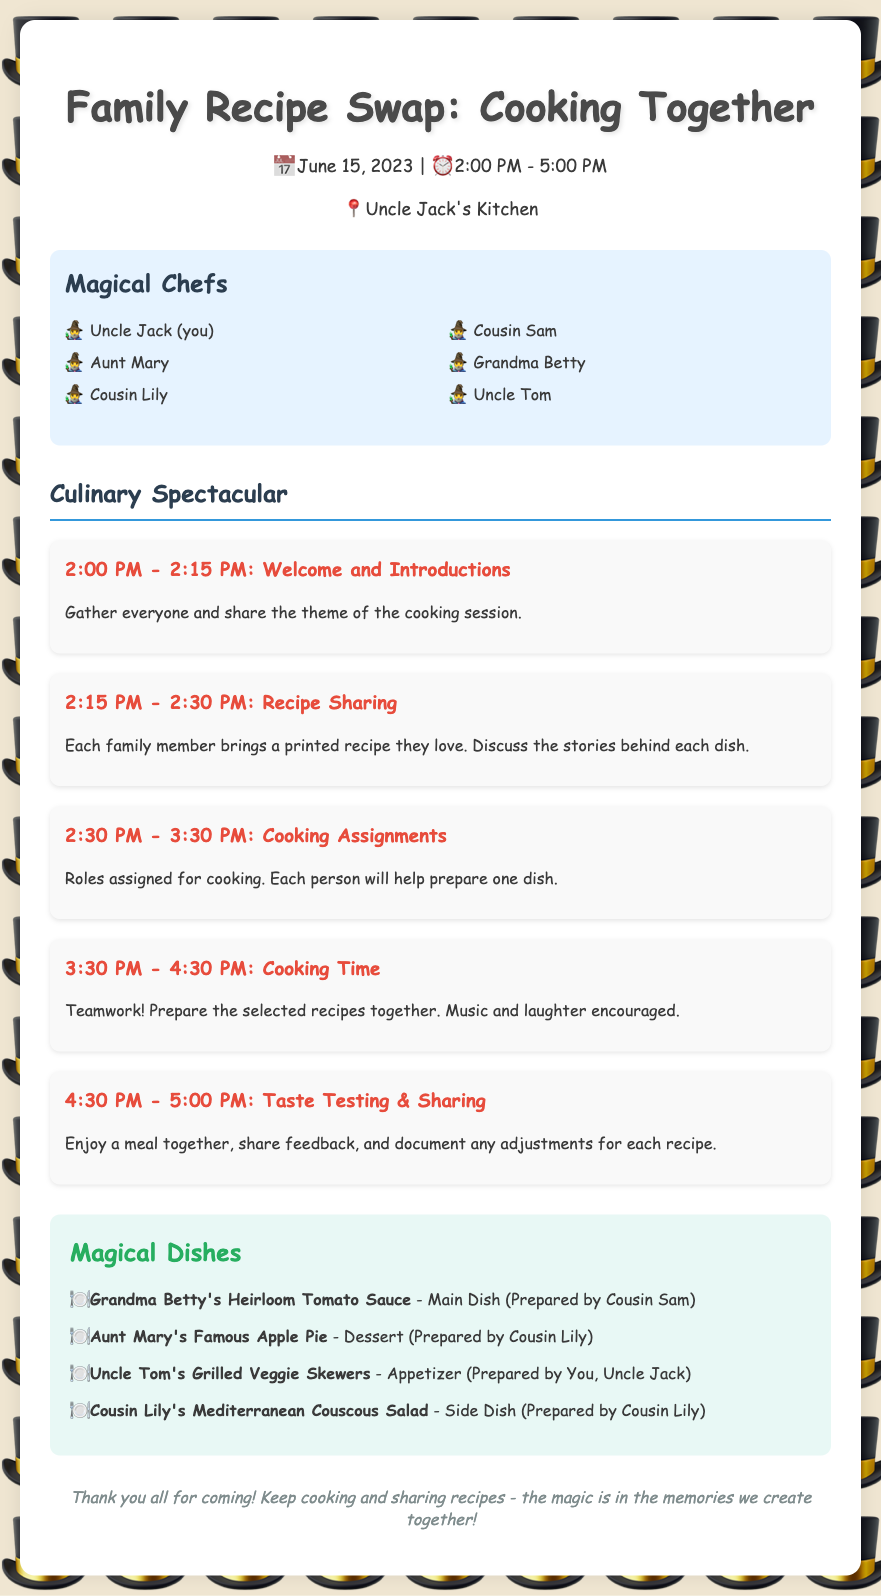What is the date of the cooking session? The date is specified in the document as June 15, 2023.
Answer: June 15, 2023 Who prepared Uncle Tom's Grilled Veggie Skewers? The document lists the person who prepared each dish, with Uncle Tom's dish prepared by Uncle Jack.
Answer: Uncle Jack What time does the cooking session start? The start time is mentioned in the document and is part of the schedule.
Answer: 2:00 PM What is the main dish prepared by Cousin Sam? The main dish is noted in the recipes section, specifically linked to Cousin Sam.
Answer: Grandma Betty's Heirloom Tomato Sauce What activity follows the Recipe Sharing? According to the schedule, the activity immediately after Recipe Sharing is Cooking Assignments.
Answer: Cooking Assignments How many participants are listed in the document? The document provides a list of participants that can be counted for the total.
Answer: 6 What type of recipe is Aunt Mary's dish? The type of recipe is specified in the recipes section, specifically mentioning its category.
Answer: Dessert What is the role of Cousin Lily in the cooking session? The document assigns Cousin Lily to prepare specific dishes and indicates her roles in the cooking activities.
Answer: Prepare dessert and side dish What is the overall theme of the cooking session? The theme is briefly described in the introduction and relates to the family gathering.
Answer: Family Recipe Swap 